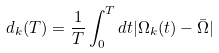<formula> <loc_0><loc_0><loc_500><loc_500>d _ { k } ( T ) = \frac { 1 } { T } \int _ { 0 } ^ { T } d t | \Omega _ { k } ( t ) - \bar { \Omega } |</formula> 